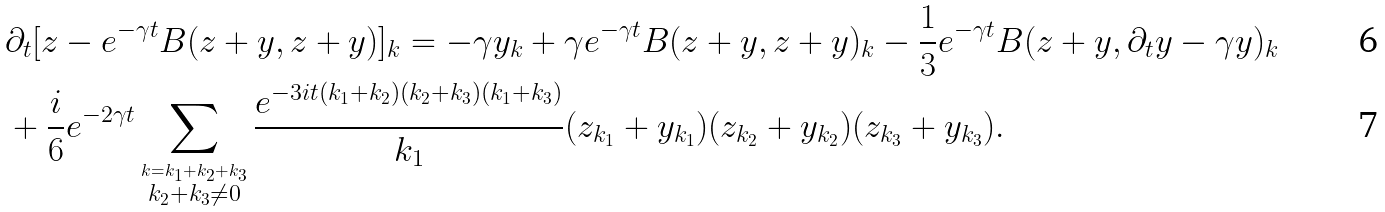<formula> <loc_0><loc_0><loc_500><loc_500>& \partial _ { t } [ z - e ^ { - \gamma t } B ( z + y , z + y ) ] _ { k } = - \gamma y _ { k } + \gamma e ^ { - \gamma t } B ( z + y , z + y ) _ { k } - \frac { 1 } { 3 } e ^ { - \gamma t } B ( z + y , \partial _ { t } y - \gamma y ) _ { k } \\ & + \frac { i } { 6 } e ^ { - 2 \gamma t } \sum _ { \stackrel { k = k _ { 1 } + k _ { 2 } + k _ { 3 } } { k _ { 2 } + k _ { 3 } \neq 0 } } \frac { e ^ { - 3 i t ( k _ { 1 } + k _ { 2 } ) ( k _ { 2 } + k _ { 3 } ) ( k _ { 1 } + k _ { 3 } ) } } { k _ { 1 } } ( z _ { k _ { 1 } } + y _ { k _ { 1 } } ) ( z _ { k _ { 2 } } + y _ { k _ { 2 } } ) ( z _ { k _ { 3 } } + y _ { k _ { 3 } } ) .</formula> 